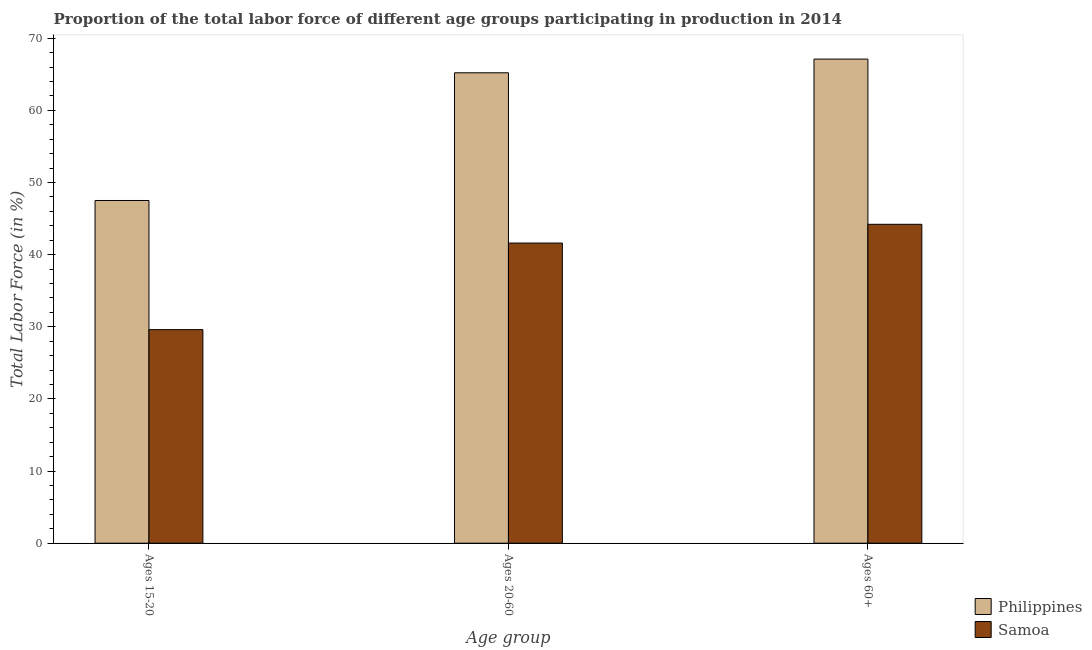Are the number of bars per tick equal to the number of legend labels?
Your answer should be compact. Yes. Are the number of bars on each tick of the X-axis equal?
Ensure brevity in your answer.  Yes. How many bars are there on the 1st tick from the left?
Offer a very short reply. 2. How many bars are there on the 1st tick from the right?
Offer a very short reply. 2. What is the label of the 3rd group of bars from the left?
Your answer should be compact. Ages 60+. What is the percentage of labor force within the age group 20-60 in Philippines?
Your answer should be very brief. 65.2. Across all countries, what is the maximum percentage of labor force within the age group 20-60?
Make the answer very short. 65.2. Across all countries, what is the minimum percentage of labor force within the age group 15-20?
Offer a terse response. 29.6. In which country was the percentage of labor force within the age group 15-20 minimum?
Give a very brief answer. Samoa. What is the total percentage of labor force above age 60 in the graph?
Your answer should be very brief. 111.3. What is the difference between the percentage of labor force within the age group 20-60 in Philippines and that in Samoa?
Provide a short and direct response. 23.6. What is the difference between the percentage of labor force above age 60 in Philippines and the percentage of labor force within the age group 20-60 in Samoa?
Make the answer very short. 25.5. What is the average percentage of labor force within the age group 15-20 per country?
Keep it short and to the point. 38.55. What is the difference between the percentage of labor force within the age group 15-20 and percentage of labor force above age 60 in Philippines?
Keep it short and to the point. -19.6. What is the ratio of the percentage of labor force within the age group 15-20 in Samoa to that in Philippines?
Keep it short and to the point. 0.62. What is the difference between the highest and the second highest percentage of labor force above age 60?
Your answer should be very brief. 22.9. What is the difference between the highest and the lowest percentage of labor force within the age group 15-20?
Your answer should be compact. 17.9. In how many countries, is the percentage of labor force above age 60 greater than the average percentage of labor force above age 60 taken over all countries?
Provide a succinct answer. 1. Is the sum of the percentage of labor force within the age group 15-20 in Samoa and Philippines greater than the maximum percentage of labor force above age 60 across all countries?
Offer a very short reply. Yes. What does the 2nd bar from the left in Ages 20-60 represents?
Provide a short and direct response. Samoa. What does the 1st bar from the right in Ages 15-20 represents?
Offer a terse response. Samoa. How many bars are there?
Your answer should be very brief. 6. Are the values on the major ticks of Y-axis written in scientific E-notation?
Offer a very short reply. No. How many legend labels are there?
Your answer should be compact. 2. How are the legend labels stacked?
Your response must be concise. Vertical. What is the title of the graph?
Give a very brief answer. Proportion of the total labor force of different age groups participating in production in 2014. What is the label or title of the X-axis?
Your response must be concise. Age group. What is the label or title of the Y-axis?
Your answer should be very brief. Total Labor Force (in %). What is the Total Labor Force (in %) of Philippines in Ages 15-20?
Your answer should be very brief. 47.5. What is the Total Labor Force (in %) of Samoa in Ages 15-20?
Your answer should be compact. 29.6. What is the Total Labor Force (in %) in Philippines in Ages 20-60?
Ensure brevity in your answer.  65.2. What is the Total Labor Force (in %) in Samoa in Ages 20-60?
Provide a short and direct response. 41.6. What is the Total Labor Force (in %) of Philippines in Ages 60+?
Your response must be concise. 67.1. What is the Total Labor Force (in %) in Samoa in Ages 60+?
Your answer should be compact. 44.2. Across all Age group, what is the maximum Total Labor Force (in %) of Philippines?
Make the answer very short. 67.1. Across all Age group, what is the maximum Total Labor Force (in %) of Samoa?
Provide a succinct answer. 44.2. Across all Age group, what is the minimum Total Labor Force (in %) of Philippines?
Offer a terse response. 47.5. Across all Age group, what is the minimum Total Labor Force (in %) of Samoa?
Offer a terse response. 29.6. What is the total Total Labor Force (in %) in Philippines in the graph?
Your response must be concise. 179.8. What is the total Total Labor Force (in %) of Samoa in the graph?
Provide a succinct answer. 115.4. What is the difference between the Total Labor Force (in %) of Philippines in Ages 15-20 and that in Ages 20-60?
Give a very brief answer. -17.7. What is the difference between the Total Labor Force (in %) of Philippines in Ages 15-20 and that in Ages 60+?
Your response must be concise. -19.6. What is the difference between the Total Labor Force (in %) of Samoa in Ages 15-20 and that in Ages 60+?
Ensure brevity in your answer.  -14.6. What is the difference between the Total Labor Force (in %) in Samoa in Ages 20-60 and that in Ages 60+?
Provide a short and direct response. -2.6. What is the average Total Labor Force (in %) in Philippines per Age group?
Make the answer very short. 59.93. What is the average Total Labor Force (in %) in Samoa per Age group?
Keep it short and to the point. 38.47. What is the difference between the Total Labor Force (in %) of Philippines and Total Labor Force (in %) of Samoa in Ages 15-20?
Your response must be concise. 17.9. What is the difference between the Total Labor Force (in %) in Philippines and Total Labor Force (in %) in Samoa in Ages 20-60?
Offer a terse response. 23.6. What is the difference between the Total Labor Force (in %) of Philippines and Total Labor Force (in %) of Samoa in Ages 60+?
Offer a very short reply. 22.9. What is the ratio of the Total Labor Force (in %) in Philippines in Ages 15-20 to that in Ages 20-60?
Provide a succinct answer. 0.73. What is the ratio of the Total Labor Force (in %) of Samoa in Ages 15-20 to that in Ages 20-60?
Your response must be concise. 0.71. What is the ratio of the Total Labor Force (in %) of Philippines in Ages 15-20 to that in Ages 60+?
Provide a succinct answer. 0.71. What is the ratio of the Total Labor Force (in %) of Samoa in Ages 15-20 to that in Ages 60+?
Provide a succinct answer. 0.67. What is the ratio of the Total Labor Force (in %) in Philippines in Ages 20-60 to that in Ages 60+?
Make the answer very short. 0.97. What is the difference between the highest and the second highest Total Labor Force (in %) of Samoa?
Provide a short and direct response. 2.6. What is the difference between the highest and the lowest Total Labor Force (in %) of Philippines?
Your response must be concise. 19.6. What is the difference between the highest and the lowest Total Labor Force (in %) in Samoa?
Your answer should be compact. 14.6. 